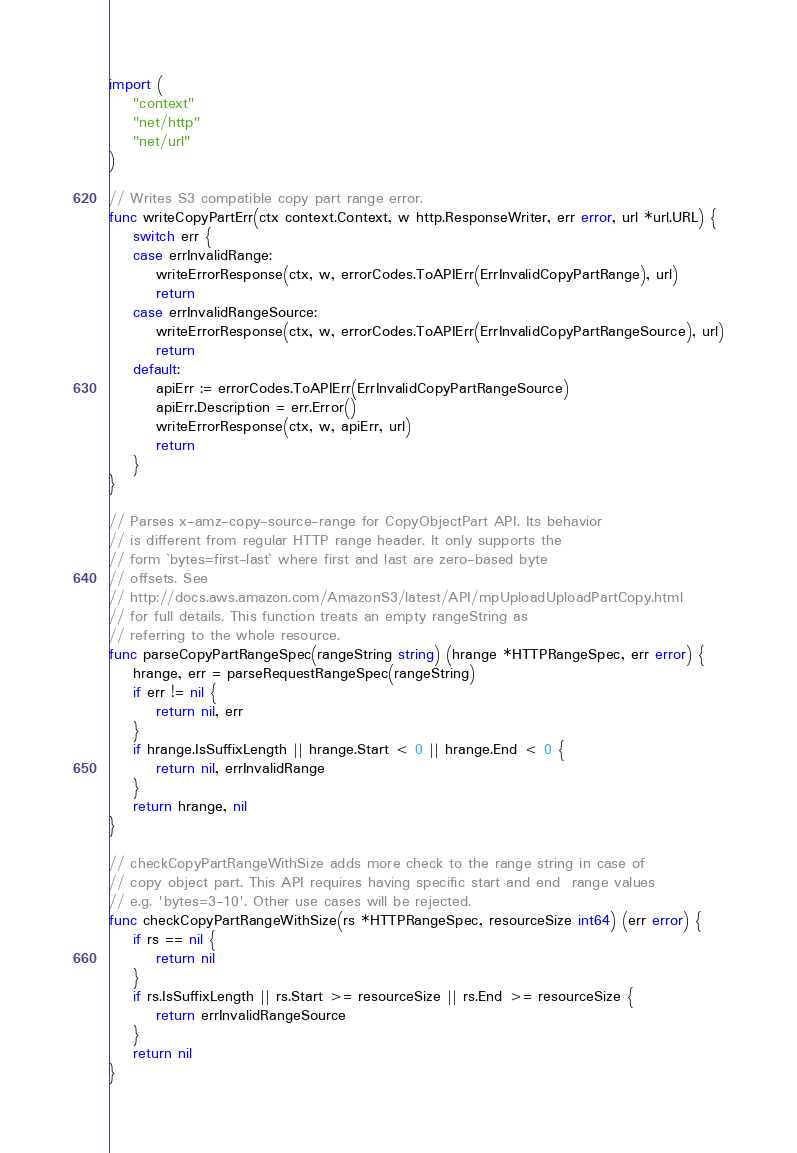<code> <loc_0><loc_0><loc_500><loc_500><_Go_>import (
	"context"
	"net/http"
	"net/url"
)

// Writes S3 compatible copy part range error.
func writeCopyPartErr(ctx context.Context, w http.ResponseWriter, err error, url *url.URL) {
	switch err {
	case errInvalidRange:
		writeErrorResponse(ctx, w, errorCodes.ToAPIErr(ErrInvalidCopyPartRange), url)
		return
	case errInvalidRangeSource:
		writeErrorResponse(ctx, w, errorCodes.ToAPIErr(ErrInvalidCopyPartRangeSource), url)
		return
	default:
		apiErr := errorCodes.ToAPIErr(ErrInvalidCopyPartRangeSource)
		apiErr.Description = err.Error()
		writeErrorResponse(ctx, w, apiErr, url)
		return
	}
}

// Parses x-amz-copy-source-range for CopyObjectPart API. Its behavior
// is different from regular HTTP range header. It only supports the
// form `bytes=first-last` where first and last are zero-based byte
// offsets. See
// http://docs.aws.amazon.com/AmazonS3/latest/API/mpUploadUploadPartCopy.html
// for full details. This function treats an empty rangeString as
// referring to the whole resource.
func parseCopyPartRangeSpec(rangeString string) (hrange *HTTPRangeSpec, err error) {
	hrange, err = parseRequestRangeSpec(rangeString)
	if err != nil {
		return nil, err
	}
	if hrange.IsSuffixLength || hrange.Start < 0 || hrange.End < 0 {
		return nil, errInvalidRange
	}
	return hrange, nil
}

// checkCopyPartRangeWithSize adds more check to the range string in case of
// copy object part. This API requires having specific start and end  range values
// e.g. 'bytes=3-10'. Other use cases will be rejected.
func checkCopyPartRangeWithSize(rs *HTTPRangeSpec, resourceSize int64) (err error) {
	if rs == nil {
		return nil
	}
	if rs.IsSuffixLength || rs.Start >= resourceSize || rs.End >= resourceSize {
		return errInvalidRangeSource
	}
	return nil
}
</code> 